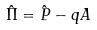Convert formula to latex. <formula><loc_0><loc_0><loc_500><loc_500>\hat { \Pi } = \hat { P } - q A</formula> 